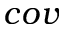<formula> <loc_0><loc_0><loc_500><loc_500>c o v</formula> 